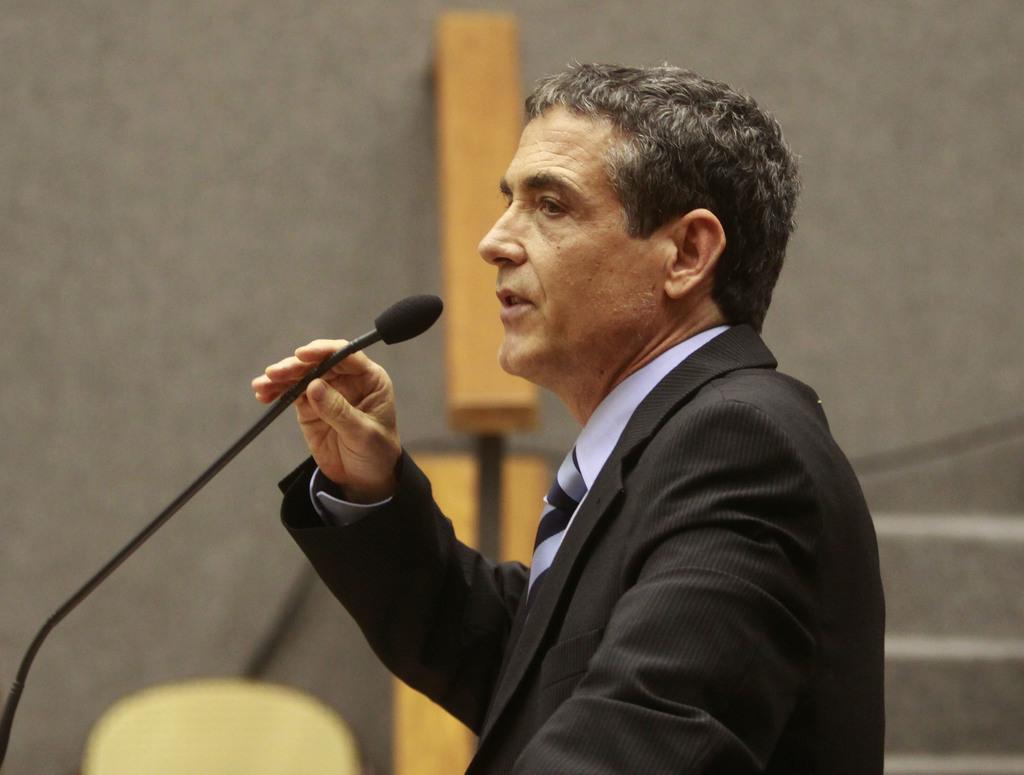Describe this image in one or two sentences. A person wearing a black coat is holding the mic and talking. In the background there is a wall. 